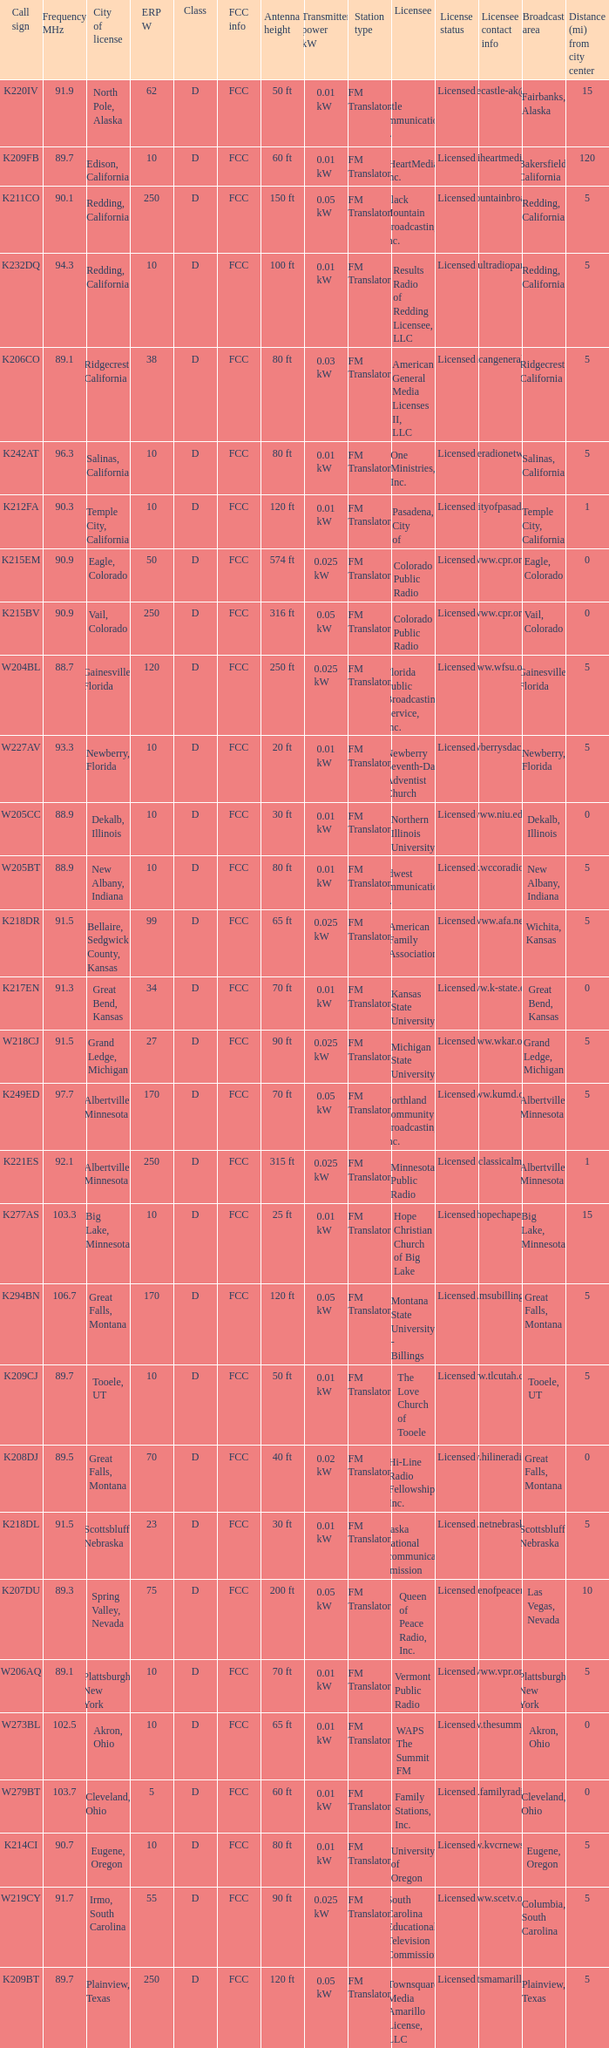What is the highest ERP W of an 89.1 frequency translator? 38.0. 